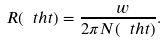Convert formula to latex. <formula><loc_0><loc_0><loc_500><loc_500>R ( \ t h t ) = \frac { \ w } { 2 \pi N ( \ t h t ) } .</formula> 